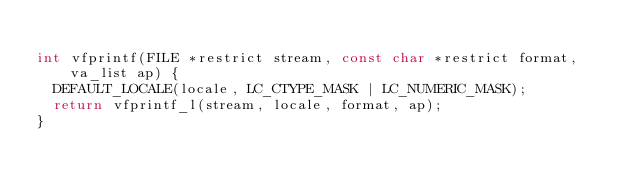<code> <loc_0><loc_0><loc_500><loc_500><_C_>
int vfprintf(FILE *restrict stream, const char *restrict format, va_list ap) {
  DEFAULT_LOCALE(locale, LC_CTYPE_MASK | LC_NUMERIC_MASK);
  return vfprintf_l(stream, locale, format, ap);
}
</code> 